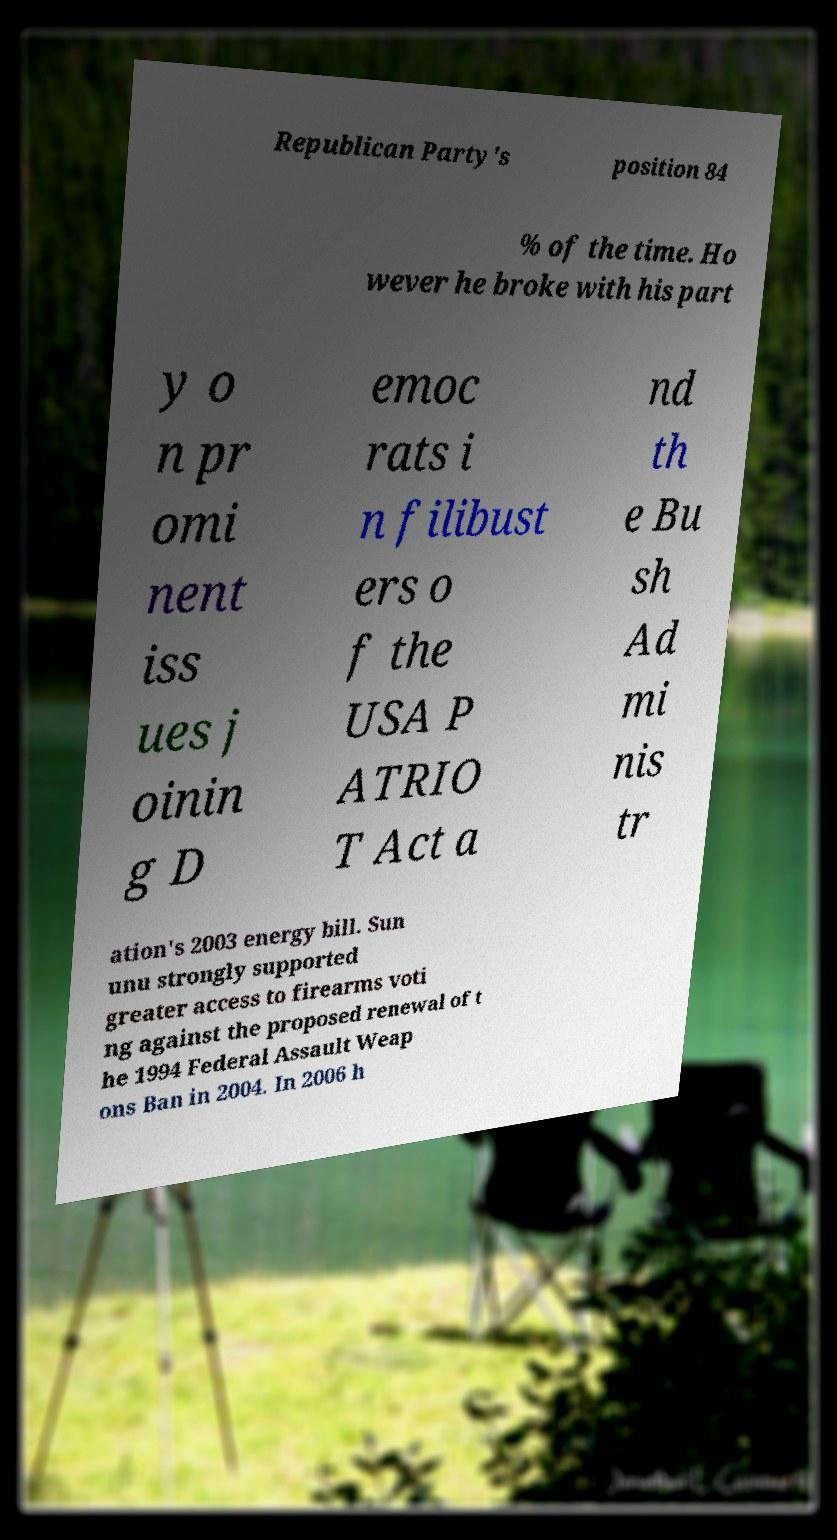Please read and relay the text visible in this image. What does it say? Republican Party's position 84 % of the time. Ho wever he broke with his part y o n pr omi nent iss ues j oinin g D emoc rats i n filibust ers o f the USA P ATRIO T Act a nd th e Bu sh Ad mi nis tr ation's 2003 energy bill. Sun unu strongly supported greater access to firearms voti ng against the proposed renewal of t he 1994 Federal Assault Weap ons Ban in 2004. In 2006 h 